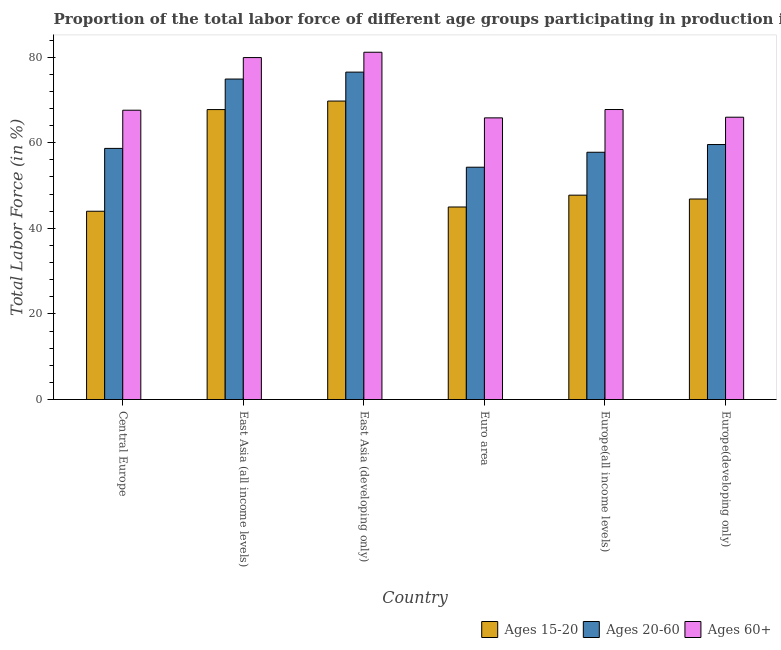How many different coloured bars are there?
Provide a short and direct response. 3. Are the number of bars per tick equal to the number of legend labels?
Your answer should be very brief. Yes. How many bars are there on the 4th tick from the left?
Your response must be concise. 3. How many bars are there on the 2nd tick from the right?
Give a very brief answer. 3. What is the label of the 5th group of bars from the left?
Your answer should be very brief. Europe(all income levels). In how many cases, is the number of bars for a given country not equal to the number of legend labels?
Give a very brief answer. 0. What is the percentage of labor force within the age group 15-20 in Europe(all income levels)?
Make the answer very short. 47.75. Across all countries, what is the maximum percentage of labor force within the age group 15-20?
Keep it short and to the point. 69.74. Across all countries, what is the minimum percentage of labor force within the age group 20-60?
Your answer should be compact. 54.28. In which country was the percentage of labor force within the age group 20-60 maximum?
Ensure brevity in your answer.  East Asia (developing only). What is the total percentage of labor force above age 60 in the graph?
Provide a succinct answer. 428.19. What is the difference between the percentage of labor force above age 60 in Europe(all income levels) and that in Europe(developing only)?
Give a very brief answer. 1.8. What is the difference between the percentage of labor force within the age group 15-20 in Euro area and the percentage of labor force above age 60 in East Asia (all income levels)?
Your answer should be compact. -34.91. What is the average percentage of labor force within the age group 20-60 per country?
Your response must be concise. 63.62. What is the difference between the percentage of labor force within the age group 20-60 and percentage of labor force within the age group 15-20 in Euro area?
Ensure brevity in your answer.  9.3. What is the ratio of the percentage of labor force within the age group 15-20 in East Asia (all income levels) to that in East Asia (developing only)?
Your response must be concise. 0.97. Is the difference between the percentage of labor force above age 60 in Europe(all income levels) and Europe(developing only) greater than the difference between the percentage of labor force within the age group 15-20 in Europe(all income levels) and Europe(developing only)?
Keep it short and to the point. Yes. What is the difference between the highest and the second highest percentage of labor force above age 60?
Provide a succinct answer. 1.25. What is the difference between the highest and the lowest percentage of labor force above age 60?
Provide a short and direct response. 15.33. What does the 2nd bar from the left in Europe(developing only) represents?
Provide a short and direct response. Ages 20-60. What does the 3rd bar from the right in East Asia (all income levels) represents?
Provide a succinct answer. Ages 15-20. How many bars are there?
Offer a terse response. 18. How many countries are there in the graph?
Give a very brief answer. 6. Are the values on the major ticks of Y-axis written in scientific E-notation?
Make the answer very short. No. Does the graph contain any zero values?
Keep it short and to the point. No. Does the graph contain grids?
Offer a terse response. No. Where does the legend appear in the graph?
Provide a succinct answer. Bottom right. What is the title of the graph?
Give a very brief answer. Proportion of the total labor force of different age groups participating in production in 1995. What is the label or title of the X-axis?
Provide a succinct answer. Country. What is the label or title of the Y-axis?
Offer a very short reply. Total Labor Force (in %). What is the Total Labor Force (in %) in Ages 15-20 in Central Europe?
Your answer should be very brief. 43.99. What is the Total Labor Force (in %) of Ages 20-60 in Central Europe?
Provide a succinct answer. 58.68. What is the Total Labor Force (in %) in Ages 60+ in Central Europe?
Offer a very short reply. 67.6. What is the Total Labor Force (in %) in Ages 15-20 in East Asia (all income levels)?
Keep it short and to the point. 67.75. What is the Total Labor Force (in %) of Ages 20-60 in East Asia (all income levels)?
Ensure brevity in your answer.  74.88. What is the Total Labor Force (in %) of Ages 60+ in East Asia (all income levels)?
Your answer should be compact. 79.9. What is the Total Labor Force (in %) of Ages 15-20 in East Asia (developing only)?
Give a very brief answer. 69.74. What is the Total Labor Force (in %) in Ages 20-60 in East Asia (developing only)?
Your answer should be very brief. 76.5. What is the Total Labor Force (in %) in Ages 60+ in East Asia (developing only)?
Keep it short and to the point. 81.15. What is the Total Labor Force (in %) of Ages 15-20 in Euro area?
Your response must be concise. 44.99. What is the Total Labor Force (in %) of Ages 20-60 in Euro area?
Make the answer very short. 54.28. What is the Total Labor Force (in %) in Ages 60+ in Euro area?
Keep it short and to the point. 65.81. What is the Total Labor Force (in %) in Ages 15-20 in Europe(all income levels)?
Your response must be concise. 47.75. What is the Total Labor Force (in %) in Ages 20-60 in Europe(all income levels)?
Give a very brief answer. 57.77. What is the Total Labor Force (in %) of Ages 60+ in Europe(all income levels)?
Your response must be concise. 67.76. What is the Total Labor Force (in %) of Ages 15-20 in Europe(developing only)?
Make the answer very short. 46.85. What is the Total Labor Force (in %) of Ages 20-60 in Europe(developing only)?
Provide a succinct answer. 59.58. What is the Total Labor Force (in %) of Ages 60+ in Europe(developing only)?
Make the answer very short. 65.96. Across all countries, what is the maximum Total Labor Force (in %) in Ages 15-20?
Provide a short and direct response. 69.74. Across all countries, what is the maximum Total Labor Force (in %) of Ages 20-60?
Provide a short and direct response. 76.5. Across all countries, what is the maximum Total Labor Force (in %) in Ages 60+?
Provide a succinct answer. 81.15. Across all countries, what is the minimum Total Labor Force (in %) in Ages 15-20?
Your answer should be very brief. 43.99. Across all countries, what is the minimum Total Labor Force (in %) in Ages 20-60?
Ensure brevity in your answer.  54.28. Across all countries, what is the minimum Total Labor Force (in %) of Ages 60+?
Your answer should be compact. 65.81. What is the total Total Labor Force (in %) of Ages 15-20 in the graph?
Provide a short and direct response. 321.07. What is the total Total Labor Force (in %) in Ages 20-60 in the graph?
Provide a succinct answer. 381.7. What is the total Total Labor Force (in %) in Ages 60+ in the graph?
Provide a short and direct response. 428.19. What is the difference between the Total Labor Force (in %) of Ages 15-20 in Central Europe and that in East Asia (all income levels)?
Give a very brief answer. -23.76. What is the difference between the Total Labor Force (in %) in Ages 20-60 in Central Europe and that in East Asia (all income levels)?
Provide a succinct answer. -16.21. What is the difference between the Total Labor Force (in %) in Ages 60+ in Central Europe and that in East Asia (all income levels)?
Offer a very short reply. -12.3. What is the difference between the Total Labor Force (in %) in Ages 15-20 in Central Europe and that in East Asia (developing only)?
Give a very brief answer. -25.75. What is the difference between the Total Labor Force (in %) of Ages 20-60 in Central Europe and that in East Asia (developing only)?
Provide a short and direct response. -17.82. What is the difference between the Total Labor Force (in %) in Ages 60+ in Central Europe and that in East Asia (developing only)?
Give a very brief answer. -13.55. What is the difference between the Total Labor Force (in %) in Ages 15-20 in Central Europe and that in Euro area?
Keep it short and to the point. -0.99. What is the difference between the Total Labor Force (in %) in Ages 20-60 in Central Europe and that in Euro area?
Keep it short and to the point. 4.4. What is the difference between the Total Labor Force (in %) of Ages 60+ in Central Europe and that in Euro area?
Provide a short and direct response. 1.79. What is the difference between the Total Labor Force (in %) of Ages 15-20 in Central Europe and that in Europe(all income levels)?
Offer a very short reply. -3.76. What is the difference between the Total Labor Force (in %) of Ages 20-60 in Central Europe and that in Europe(all income levels)?
Offer a very short reply. 0.9. What is the difference between the Total Labor Force (in %) of Ages 60+ in Central Europe and that in Europe(all income levels)?
Your answer should be very brief. -0.16. What is the difference between the Total Labor Force (in %) in Ages 15-20 in Central Europe and that in Europe(developing only)?
Offer a very short reply. -2.86. What is the difference between the Total Labor Force (in %) in Ages 20-60 in Central Europe and that in Europe(developing only)?
Make the answer very short. -0.9. What is the difference between the Total Labor Force (in %) in Ages 60+ in Central Europe and that in Europe(developing only)?
Ensure brevity in your answer.  1.64. What is the difference between the Total Labor Force (in %) of Ages 15-20 in East Asia (all income levels) and that in East Asia (developing only)?
Make the answer very short. -1.99. What is the difference between the Total Labor Force (in %) in Ages 20-60 in East Asia (all income levels) and that in East Asia (developing only)?
Provide a short and direct response. -1.62. What is the difference between the Total Labor Force (in %) of Ages 60+ in East Asia (all income levels) and that in East Asia (developing only)?
Offer a terse response. -1.25. What is the difference between the Total Labor Force (in %) in Ages 15-20 in East Asia (all income levels) and that in Euro area?
Provide a short and direct response. 22.76. What is the difference between the Total Labor Force (in %) of Ages 20-60 in East Asia (all income levels) and that in Euro area?
Ensure brevity in your answer.  20.6. What is the difference between the Total Labor Force (in %) in Ages 60+ in East Asia (all income levels) and that in Euro area?
Give a very brief answer. 14.09. What is the difference between the Total Labor Force (in %) in Ages 15-20 in East Asia (all income levels) and that in Europe(all income levels)?
Provide a short and direct response. 20. What is the difference between the Total Labor Force (in %) in Ages 20-60 in East Asia (all income levels) and that in Europe(all income levels)?
Offer a terse response. 17.11. What is the difference between the Total Labor Force (in %) in Ages 60+ in East Asia (all income levels) and that in Europe(all income levels)?
Your response must be concise. 12.14. What is the difference between the Total Labor Force (in %) of Ages 15-20 in East Asia (all income levels) and that in Europe(developing only)?
Provide a succinct answer. 20.9. What is the difference between the Total Labor Force (in %) of Ages 20-60 in East Asia (all income levels) and that in Europe(developing only)?
Your response must be concise. 15.3. What is the difference between the Total Labor Force (in %) of Ages 60+ in East Asia (all income levels) and that in Europe(developing only)?
Offer a terse response. 13.94. What is the difference between the Total Labor Force (in %) in Ages 15-20 in East Asia (developing only) and that in Euro area?
Keep it short and to the point. 24.75. What is the difference between the Total Labor Force (in %) in Ages 20-60 in East Asia (developing only) and that in Euro area?
Provide a short and direct response. 22.22. What is the difference between the Total Labor Force (in %) of Ages 60+ in East Asia (developing only) and that in Euro area?
Provide a succinct answer. 15.33. What is the difference between the Total Labor Force (in %) of Ages 15-20 in East Asia (developing only) and that in Europe(all income levels)?
Offer a terse response. 21.99. What is the difference between the Total Labor Force (in %) of Ages 20-60 in East Asia (developing only) and that in Europe(all income levels)?
Ensure brevity in your answer.  18.73. What is the difference between the Total Labor Force (in %) of Ages 60+ in East Asia (developing only) and that in Europe(all income levels)?
Your response must be concise. 13.39. What is the difference between the Total Labor Force (in %) of Ages 15-20 in East Asia (developing only) and that in Europe(developing only)?
Give a very brief answer. 22.89. What is the difference between the Total Labor Force (in %) in Ages 20-60 in East Asia (developing only) and that in Europe(developing only)?
Provide a succinct answer. 16.92. What is the difference between the Total Labor Force (in %) of Ages 60+ in East Asia (developing only) and that in Europe(developing only)?
Give a very brief answer. 15.18. What is the difference between the Total Labor Force (in %) of Ages 15-20 in Euro area and that in Europe(all income levels)?
Offer a terse response. -2.76. What is the difference between the Total Labor Force (in %) in Ages 20-60 in Euro area and that in Europe(all income levels)?
Provide a succinct answer. -3.49. What is the difference between the Total Labor Force (in %) of Ages 60+ in Euro area and that in Europe(all income levels)?
Keep it short and to the point. -1.95. What is the difference between the Total Labor Force (in %) of Ages 15-20 in Euro area and that in Europe(developing only)?
Keep it short and to the point. -1.86. What is the difference between the Total Labor Force (in %) of Ages 20-60 in Euro area and that in Europe(developing only)?
Give a very brief answer. -5.3. What is the difference between the Total Labor Force (in %) in Ages 60+ in Euro area and that in Europe(developing only)?
Offer a very short reply. -0.15. What is the difference between the Total Labor Force (in %) of Ages 15-20 in Europe(all income levels) and that in Europe(developing only)?
Give a very brief answer. 0.9. What is the difference between the Total Labor Force (in %) of Ages 20-60 in Europe(all income levels) and that in Europe(developing only)?
Your response must be concise. -1.8. What is the difference between the Total Labor Force (in %) in Ages 60+ in Europe(all income levels) and that in Europe(developing only)?
Make the answer very short. 1.8. What is the difference between the Total Labor Force (in %) in Ages 15-20 in Central Europe and the Total Labor Force (in %) in Ages 20-60 in East Asia (all income levels)?
Provide a succinct answer. -30.89. What is the difference between the Total Labor Force (in %) in Ages 15-20 in Central Europe and the Total Labor Force (in %) in Ages 60+ in East Asia (all income levels)?
Provide a succinct answer. -35.91. What is the difference between the Total Labor Force (in %) of Ages 20-60 in Central Europe and the Total Labor Force (in %) of Ages 60+ in East Asia (all income levels)?
Offer a terse response. -21.22. What is the difference between the Total Labor Force (in %) of Ages 15-20 in Central Europe and the Total Labor Force (in %) of Ages 20-60 in East Asia (developing only)?
Provide a succinct answer. -32.51. What is the difference between the Total Labor Force (in %) of Ages 15-20 in Central Europe and the Total Labor Force (in %) of Ages 60+ in East Asia (developing only)?
Keep it short and to the point. -37.15. What is the difference between the Total Labor Force (in %) in Ages 20-60 in Central Europe and the Total Labor Force (in %) in Ages 60+ in East Asia (developing only)?
Make the answer very short. -22.47. What is the difference between the Total Labor Force (in %) in Ages 15-20 in Central Europe and the Total Labor Force (in %) in Ages 20-60 in Euro area?
Provide a short and direct response. -10.29. What is the difference between the Total Labor Force (in %) of Ages 15-20 in Central Europe and the Total Labor Force (in %) of Ages 60+ in Euro area?
Offer a terse response. -21.82. What is the difference between the Total Labor Force (in %) in Ages 20-60 in Central Europe and the Total Labor Force (in %) in Ages 60+ in Euro area?
Keep it short and to the point. -7.13. What is the difference between the Total Labor Force (in %) of Ages 15-20 in Central Europe and the Total Labor Force (in %) of Ages 20-60 in Europe(all income levels)?
Give a very brief answer. -13.78. What is the difference between the Total Labor Force (in %) of Ages 15-20 in Central Europe and the Total Labor Force (in %) of Ages 60+ in Europe(all income levels)?
Ensure brevity in your answer.  -23.77. What is the difference between the Total Labor Force (in %) in Ages 20-60 in Central Europe and the Total Labor Force (in %) in Ages 60+ in Europe(all income levels)?
Provide a short and direct response. -9.08. What is the difference between the Total Labor Force (in %) of Ages 15-20 in Central Europe and the Total Labor Force (in %) of Ages 20-60 in Europe(developing only)?
Make the answer very short. -15.59. What is the difference between the Total Labor Force (in %) of Ages 15-20 in Central Europe and the Total Labor Force (in %) of Ages 60+ in Europe(developing only)?
Keep it short and to the point. -21.97. What is the difference between the Total Labor Force (in %) of Ages 20-60 in Central Europe and the Total Labor Force (in %) of Ages 60+ in Europe(developing only)?
Offer a terse response. -7.28. What is the difference between the Total Labor Force (in %) of Ages 15-20 in East Asia (all income levels) and the Total Labor Force (in %) of Ages 20-60 in East Asia (developing only)?
Provide a short and direct response. -8.75. What is the difference between the Total Labor Force (in %) in Ages 15-20 in East Asia (all income levels) and the Total Labor Force (in %) in Ages 60+ in East Asia (developing only)?
Keep it short and to the point. -13.4. What is the difference between the Total Labor Force (in %) in Ages 20-60 in East Asia (all income levels) and the Total Labor Force (in %) in Ages 60+ in East Asia (developing only)?
Give a very brief answer. -6.26. What is the difference between the Total Labor Force (in %) in Ages 15-20 in East Asia (all income levels) and the Total Labor Force (in %) in Ages 20-60 in Euro area?
Offer a terse response. 13.47. What is the difference between the Total Labor Force (in %) in Ages 15-20 in East Asia (all income levels) and the Total Labor Force (in %) in Ages 60+ in Euro area?
Give a very brief answer. 1.94. What is the difference between the Total Labor Force (in %) in Ages 20-60 in East Asia (all income levels) and the Total Labor Force (in %) in Ages 60+ in Euro area?
Offer a very short reply. 9.07. What is the difference between the Total Labor Force (in %) of Ages 15-20 in East Asia (all income levels) and the Total Labor Force (in %) of Ages 20-60 in Europe(all income levels)?
Keep it short and to the point. 9.98. What is the difference between the Total Labor Force (in %) of Ages 15-20 in East Asia (all income levels) and the Total Labor Force (in %) of Ages 60+ in Europe(all income levels)?
Give a very brief answer. -0.01. What is the difference between the Total Labor Force (in %) of Ages 20-60 in East Asia (all income levels) and the Total Labor Force (in %) of Ages 60+ in Europe(all income levels)?
Keep it short and to the point. 7.12. What is the difference between the Total Labor Force (in %) of Ages 15-20 in East Asia (all income levels) and the Total Labor Force (in %) of Ages 20-60 in Europe(developing only)?
Offer a very short reply. 8.17. What is the difference between the Total Labor Force (in %) of Ages 15-20 in East Asia (all income levels) and the Total Labor Force (in %) of Ages 60+ in Europe(developing only)?
Provide a succinct answer. 1.79. What is the difference between the Total Labor Force (in %) of Ages 20-60 in East Asia (all income levels) and the Total Labor Force (in %) of Ages 60+ in Europe(developing only)?
Ensure brevity in your answer.  8.92. What is the difference between the Total Labor Force (in %) in Ages 15-20 in East Asia (developing only) and the Total Labor Force (in %) in Ages 20-60 in Euro area?
Your response must be concise. 15.46. What is the difference between the Total Labor Force (in %) in Ages 15-20 in East Asia (developing only) and the Total Labor Force (in %) in Ages 60+ in Euro area?
Your answer should be compact. 3.93. What is the difference between the Total Labor Force (in %) in Ages 20-60 in East Asia (developing only) and the Total Labor Force (in %) in Ages 60+ in Euro area?
Ensure brevity in your answer.  10.69. What is the difference between the Total Labor Force (in %) of Ages 15-20 in East Asia (developing only) and the Total Labor Force (in %) of Ages 20-60 in Europe(all income levels)?
Provide a succinct answer. 11.97. What is the difference between the Total Labor Force (in %) of Ages 15-20 in East Asia (developing only) and the Total Labor Force (in %) of Ages 60+ in Europe(all income levels)?
Provide a short and direct response. 1.98. What is the difference between the Total Labor Force (in %) of Ages 20-60 in East Asia (developing only) and the Total Labor Force (in %) of Ages 60+ in Europe(all income levels)?
Your answer should be compact. 8.74. What is the difference between the Total Labor Force (in %) in Ages 15-20 in East Asia (developing only) and the Total Labor Force (in %) in Ages 20-60 in Europe(developing only)?
Give a very brief answer. 10.16. What is the difference between the Total Labor Force (in %) of Ages 15-20 in East Asia (developing only) and the Total Labor Force (in %) of Ages 60+ in Europe(developing only)?
Your response must be concise. 3.78. What is the difference between the Total Labor Force (in %) in Ages 20-60 in East Asia (developing only) and the Total Labor Force (in %) in Ages 60+ in Europe(developing only)?
Ensure brevity in your answer.  10.54. What is the difference between the Total Labor Force (in %) in Ages 15-20 in Euro area and the Total Labor Force (in %) in Ages 20-60 in Europe(all income levels)?
Keep it short and to the point. -12.79. What is the difference between the Total Labor Force (in %) of Ages 15-20 in Euro area and the Total Labor Force (in %) of Ages 60+ in Europe(all income levels)?
Ensure brevity in your answer.  -22.77. What is the difference between the Total Labor Force (in %) of Ages 20-60 in Euro area and the Total Labor Force (in %) of Ages 60+ in Europe(all income levels)?
Offer a terse response. -13.48. What is the difference between the Total Labor Force (in %) of Ages 15-20 in Euro area and the Total Labor Force (in %) of Ages 20-60 in Europe(developing only)?
Your answer should be compact. -14.59. What is the difference between the Total Labor Force (in %) in Ages 15-20 in Euro area and the Total Labor Force (in %) in Ages 60+ in Europe(developing only)?
Keep it short and to the point. -20.98. What is the difference between the Total Labor Force (in %) in Ages 20-60 in Euro area and the Total Labor Force (in %) in Ages 60+ in Europe(developing only)?
Your response must be concise. -11.68. What is the difference between the Total Labor Force (in %) in Ages 15-20 in Europe(all income levels) and the Total Labor Force (in %) in Ages 20-60 in Europe(developing only)?
Your response must be concise. -11.83. What is the difference between the Total Labor Force (in %) of Ages 15-20 in Europe(all income levels) and the Total Labor Force (in %) of Ages 60+ in Europe(developing only)?
Ensure brevity in your answer.  -18.21. What is the difference between the Total Labor Force (in %) in Ages 20-60 in Europe(all income levels) and the Total Labor Force (in %) in Ages 60+ in Europe(developing only)?
Your answer should be very brief. -8.19. What is the average Total Labor Force (in %) of Ages 15-20 per country?
Your response must be concise. 53.51. What is the average Total Labor Force (in %) of Ages 20-60 per country?
Offer a terse response. 63.62. What is the average Total Labor Force (in %) in Ages 60+ per country?
Your response must be concise. 71.36. What is the difference between the Total Labor Force (in %) of Ages 15-20 and Total Labor Force (in %) of Ages 20-60 in Central Europe?
Give a very brief answer. -14.69. What is the difference between the Total Labor Force (in %) in Ages 15-20 and Total Labor Force (in %) in Ages 60+ in Central Europe?
Your response must be concise. -23.61. What is the difference between the Total Labor Force (in %) in Ages 20-60 and Total Labor Force (in %) in Ages 60+ in Central Europe?
Your answer should be very brief. -8.92. What is the difference between the Total Labor Force (in %) of Ages 15-20 and Total Labor Force (in %) of Ages 20-60 in East Asia (all income levels)?
Offer a very short reply. -7.13. What is the difference between the Total Labor Force (in %) in Ages 15-20 and Total Labor Force (in %) in Ages 60+ in East Asia (all income levels)?
Your answer should be very brief. -12.15. What is the difference between the Total Labor Force (in %) in Ages 20-60 and Total Labor Force (in %) in Ages 60+ in East Asia (all income levels)?
Offer a terse response. -5.02. What is the difference between the Total Labor Force (in %) of Ages 15-20 and Total Labor Force (in %) of Ages 20-60 in East Asia (developing only)?
Your answer should be very brief. -6.76. What is the difference between the Total Labor Force (in %) of Ages 15-20 and Total Labor Force (in %) of Ages 60+ in East Asia (developing only)?
Your answer should be compact. -11.41. What is the difference between the Total Labor Force (in %) of Ages 20-60 and Total Labor Force (in %) of Ages 60+ in East Asia (developing only)?
Keep it short and to the point. -4.64. What is the difference between the Total Labor Force (in %) in Ages 15-20 and Total Labor Force (in %) in Ages 20-60 in Euro area?
Your response must be concise. -9.3. What is the difference between the Total Labor Force (in %) of Ages 15-20 and Total Labor Force (in %) of Ages 60+ in Euro area?
Make the answer very short. -20.83. What is the difference between the Total Labor Force (in %) of Ages 20-60 and Total Labor Force (in %) of Ages 60+ in Euro area?
Keep it short and to the point. -11.53. What is the difference between the Total Labor Force (in %) of Ages 15-20 and Total Labor Force (in %) of Ages 20-60 in Europe(all income levels)?
Make the answer very short. -10.03. What is the difference between the Total Labor Force (in %) of Ages 15-20 and Total Labor Force (in %) of Ages 60+ in Europe(all income levels)?
Your response must be concise. -20.01. What is the difference between the Total Labor Force (in %) of Ages 20-60 and Total Labor Force (in %) of Ages 60+ in Europe(all income levels)?
Make the answer very short. -9.99. What is the difference between the Total Labor Force (in %) in Ages 15-20 and Total Labor Force (in %) in Ages 20-60 in Europe(developing only)?
Keep it short and to the point. -12.73. What is the difference between the Total Labor Force (in %) of Ages 15-20 and Total Labor Force (in %) of Ages 60+ in Europe(developing only)?
Give a very brief answer. -19.11. What is the difference between the Total Labor Force (in %) of Ages 20-60 and Total Labor Force (in %) of Ages 60+ in Europe(developing only)?
Provide a succinct answer. -6.38. What is the ratio of the Total Labor Force (in %) of Ages 15-20 in Central Europe to that in East Asia (all income levels)?
Provide a short and direct response. 0.65. What is the ratio of the Total Labor Force (in %) of Ages 20-60 in Central Europe to that in East Asia (all income levels)?
Offer a terse response. 0.78. What is the ratio of the Total Labor Force (in %) of Ages 60+ in Central Europe to that in East Asia (all income levels)?
Provide a short and direct response. 0.85. What is the ratio of the Total Labor Force (in %) in Ages 15-20 in Central Europe to that in East Asia (developing only)?
Give a very brief answer. 0.63. What is the ratio of the Total Labor Force (in %) in Ages 20-60 in Central Europe to that in East Asia (developing only)?
Offer a very short reply. 0.77. What is the ratio of the Total Labor Force (in %) of Ages 60+ in Central Europe to that in East Asia (developing only)?
Provide a succinct answer. 0.83. What is the ratio of the Total Labor Force (in %) of Ages 15-20 in Central Europe to that in Euro area?
Keep it short and to the point. 0.98. What is the ratio of the Total Labor Force (in %) in Ages 20-60 in Central Europe to that in Euro area?
Your answer should be very brief. 1.08. What is the ratio of the Total Labor Force (in %) of Ages 60+ in Central Europe to that in Euro area?
Ensure brevity in your answer.  1.03. What is the ratio of the Total Labor Force (in %) of Ages 15-20 in Central Europe to that in Europe(all income levels)?
Make the answer very short. 0.92. What is the ratio of the Total Labor Force (in %) of Ages 20-60 in Central Europe to that in Europe(all income levels)?
Give a very brief answer. 1.02. What is the ratio of the Total Labor Force (in %) in Ages 15-20 in Central Europe to that in Europe(developing only)?
Provide a succinct answer. 0.94. What is the ratio of the Total Labor Force (in %) of Ages 20-60 in Central Europe to that in Europe(developing only)?
Make the answer very short. 0.98. What is the ratio of the Total Labor Force (in %) of Ages 60+ in Central Europe to that in Europe(developing only)?
Provide a succinct answer. 1.02. What is the ratio of the Total Labor Force (in %) of Ages 15-20 in East Asia (all income levels) to that in East Asia (developing only)?
Give a very brief answer. 0.97. What is the ratio of the Total Labor Force (in %) in Ages 20-60 in East Asia (all income levels) to that in East Asia (developing only)?
Keep it short and to the point. 0.98. What is the ratio of the Total Labor Force (in %) of Ages 60+ in East Asia (all income levels) to that in East Asia (developing only)?
Your response must be concise. 0.98. What is the ratio of the Total Labor Force (in %) in Ages 15-20 in East Asia (all income levels) to that in Euro area?
Provide a succinct answer. 1.51. What is the ratio of the Total Labor Force (in %) in Ages 20-60 in East Asia (all income levels) to that in Euro area?
Offer a very short reply. 1.38. What is the ratio of the Total Labor Force (in %) of Ages 60+ in East Asia (all income levels) to that in Euro area?
Your answer should be very brief. 1.21. What is the ratio of the Total Labor Force (in %) of Ages 15-20 in East Asia (all income levels) to that in Europe(all income levels)?
Your answer should be compact. 1.42. What is the ratio of the Total Labor Force (in %) of Ages 20-60 in East Asia (all income levels) to that in Europe(all income levels)?
Provide a succinct answer. 1.3. What is the ratio of the Total Labor Force (in %) of Ages 60+ in East Asia (all income levels) to that in Europe(all income levels)?
Your answer should be compact. 1.18. What is the ratio of the Total Labor Force (in %) in Ages 15-20 in East Asia (all income levels) to that in Europe(developing only)?
Your answer should be very brief. 1.45. What is the ratio of the Total Labor Force (in %) of Ages 20-60 in East Asia (all income levels) to that in Europe(developing only)?
Offer a terse response. 1.26. What is the ratio of the Total Labor Force (in %) in Ages 60+ in East Asia (all income levels) to that in Europe(developing only)?
Ensure brevity in your answer.  1.21. What is the ratio of the Total Labor Force (in %) of Ages 15-20 in East Asia (developing only) to that in Euro area?
Ensure brevity in your answer.  1.55. What is the ratio of the Total Labor Force (in %) in Ages 20-60 in East Asia (developing only) to that in Euro area?
Provide a short and direct response. 1.41. What is the ratio of the Total Labor Force (in %) of Ages 60+ in East Asia (developing only) to that in Euro area?
Keep it short and to the point. 1.23. What is the ratio of the Total Labor Force (in %) of Ages 15-20 in East Asia (developing only) to that in Europe(all income levels)?
Ensure brevity in your answer.  1.46. What is the ratio of the Total Labor Force (in %) in Ages 20-60 in East Asia (developing only) to that in Europe(all income levels)?
Make the answer very short. 1.32. What is the ratio of the Total Labor Force (in %) of Ages 60+ in East Asia (developing only) to that in Europe(all income levels)?
Provide a short and direct response. 1.2. What is the ratio of the Total Labor Force (in %) of Ages 15-20 in East Asia (developing only) to that in Europe(developing only)?
Offer a terse response. 1.49. What is the ratio of the Total Labor Force (in %) of Ages 20-60 in East Asia (developing only) to that in Europe(developing only)?
Give a very brief answer. 1.28. What is the ratio of the Total Labor Force (in %) of Ages 60+ in East Asia (developing only) to that in Europe(developing only)?
Ensure brevity in your answer.  1.23. What is the ratio of the Total Labor Force (in %) of Ages 15-20 in Euro area to that in Europe(all income levels)?
Your answer should be very brief. 0.94. What is the ratio of the Total Labor Force (in %) in Ages 20-60 in Euro area to that in Europe(all income levels)?
Provide a short and direct response. 0.94. What is the ratio of the Total Labor Force (in %) of Ages 60+ in Euro area to that in Europe(all income levels)?
Offer a very short reply. 0.97. What is the ratio of the Total Labor Force (in %) in Ages 15-20 in Euro area to that in Europe(developing only)?
Offer a very short reply. 0.96. What is the ratio of the Total Labor Force (in %) of Ages 20-60 in Euro area to that in Europe(developing only)?
Offer a terse response. 0.91. What is the ratio of the Total Labor Force (in %) of Ages 15-20 in Europe(all income levels) to that in Europe(developing only)?
Keep it short and to the point. 1.02. What is the ratio of the Total Labor Force (in %) of Ages 20-60 in Europe(all income levels) to that in Europe(developing only)?
Keep it short and to the point. 0.97. What is the ratio of the Total Labor Force (in %) of Ages 60+ in Europe(all income levels) to that in Europe(developing only)?
Offer a terse response. 1.03. What is the difference between the highest and the second highest Total Labor Force (in %) in Ages 15-20?
Provide a succinct answer. 1.99. What is the difference between the highest and the second highest Total Labor Force (in %) of Ages 20-60?
Provide a short and direct response. 1.62. What is the difference between the highest and the second highest Total Labor Force (in %) of Ages 60+?
Offer a terse response. 1.25. What is the difference between the highest and the lowest Total Labor Force (in %) in Ages 15-20?
Offer a terse response. 25.75. What is the difference between the highest and the lowest Total Labor Force (in %) in Ages 20-60?
Your answer should be very brief. 22.22. What is the difference between the highest and the lowest Total Labor Force (in %) of Ages 60+?
Provide a short and direct response. 15.33. 